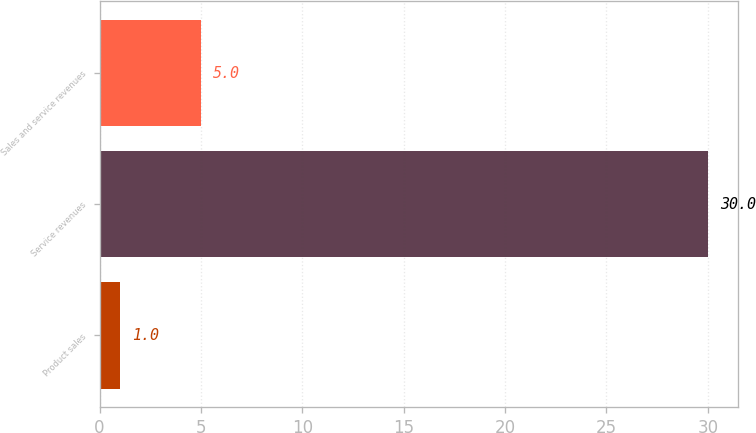Convert chart. <chart><loc_0><loc_0><loc_500><loc_500><bar_chart><fcel>Product sales<fcel>Service revenues<fcel>Sales and service revenues<nl><fcel>1<fcel>30<fcel>5<nl></chart> 